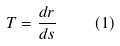Convert formula to latex. <formula><loc_0><loc_0><loc_500><loc_500>T = { \frac { d r } { d s } } \quad ( 1 )</formula> 